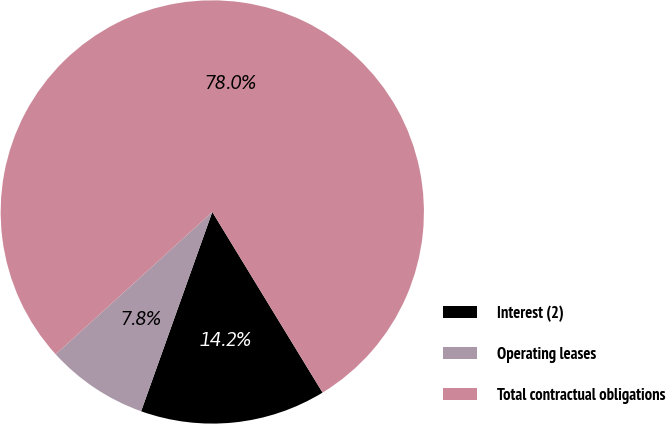Convert chart. <chart><loc_0><loc_0><loc_500><loc_500><pie_chart><fcel>Interest (2)<fcel>Operating leases<fcel>Total contractual obligations<nl><fcel>14.18%<fcel>7.8%<fcel>78.01%<nl></chart> 